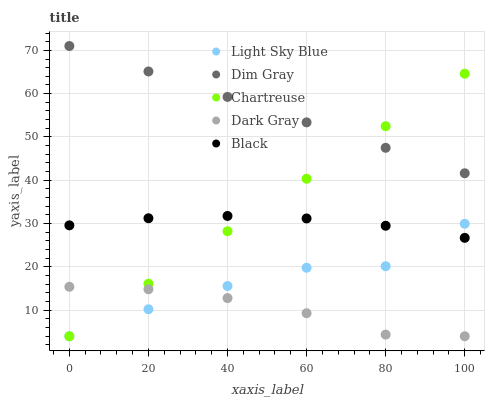Does Dark Gray have the minimum area under the curve?
Answer yes or no. Yes. Does Dim Gray have the maximum area under the curve?
Answer yes or no. Yes. Does Light Sky Blue have the minimum area under the curve?
Answer yes or no. No. Does Light Sky Blue have the maximum area under the curve?
Answer yes or no. No. Is Chartreuse the smoothest?
Answer yes or no. Yes. Is Light Sky Blue the roughest?
Answer yes or no. Yes. Is Dim Gray the smoothest?
Answer yes or no. No. Is Dim Gray the roughest?
Answer yes or no. No. Does Dark Gray have the lowest value?
Answer yes or no. Yes. Does Dim Gray have the lowest value?
Answer yes or no. No. Does Dim Gray have the highest value?
Answer yes or no. Yes. Does Light Sky Blue have the highest value?
Answer yes or no. No. Is Black less than Dim Gray?
Answer yes or no. Yes. Is Black greater than Dark Gray?
Answer yes or no. Yes. Does Chartreuse intersect Dim Gray?
Answer yes or no. Yes. Is Chartreuse less than Dim Gray?
Answer yes or no. No. Is Chartreuse greater than Dim Gray?
Answer yes or no. No. Does Black intersect Dim Gray?
Answer yes or no. No. 